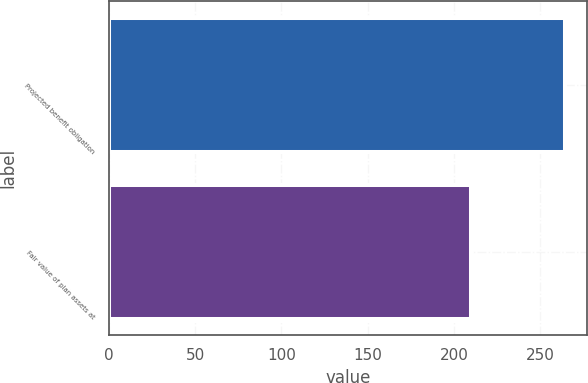Convert chart. <chart><loc_0><loc_0><loc_500><loc_500><bar_chart><fcel>Projected benefit obligation<fcel>Fair value of plan assets at<nl><fcel>264<fcel>210<nl></chart> 